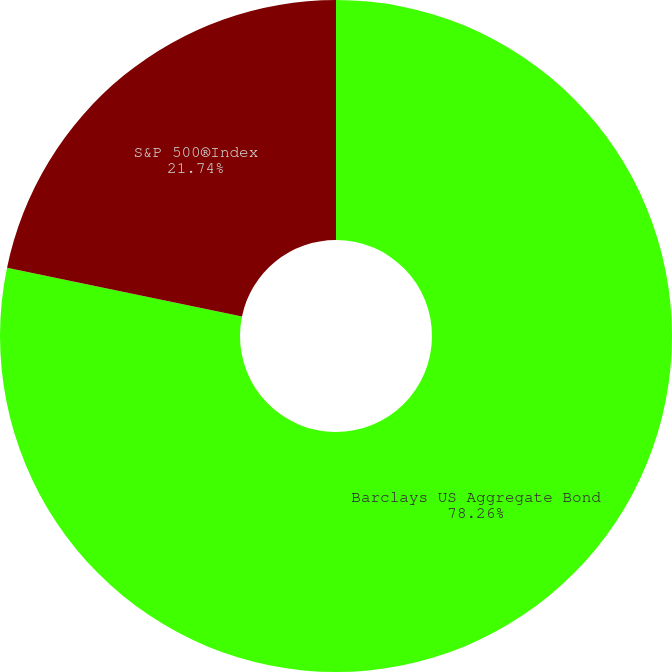Convert chart. <chart><loc_0><loc_0><loc_500><loc_500><pie_chart><fcel>Barclays US Aggregate Bond<fcel>S&P 500®Index<nl><fcel>78.26%<fcel>21.74%<nl></chart> 